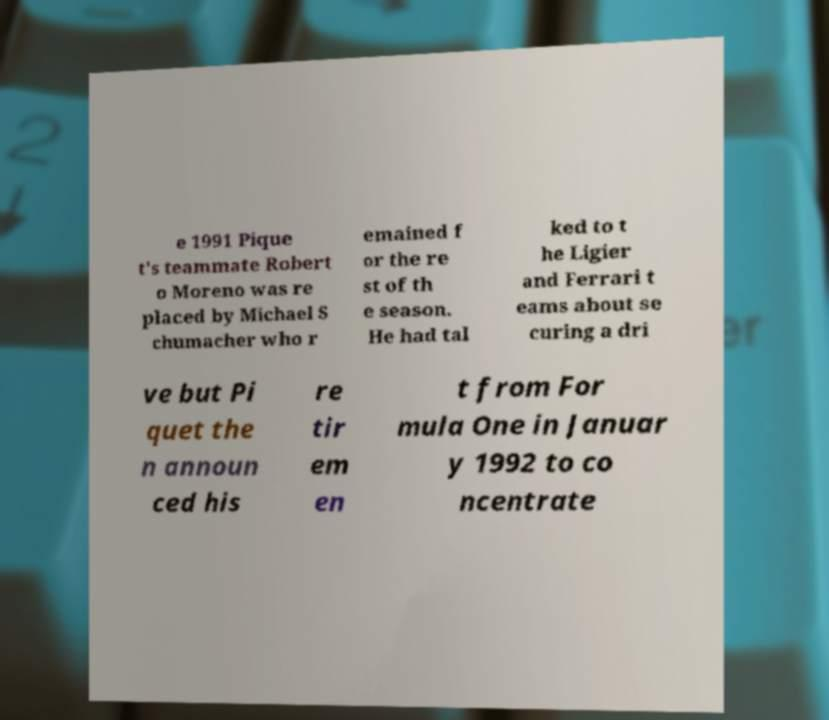Can you accurately transcribe the text from the provided image for me? e 1991 Pique t's teammate Robert o Moreno was re placed by Michael S chumacher who r emained f or the re st of th e season. He had tal ked to t he Ligier and Ferrari t eams about se curing a dri ve but Pi quet the n announ ced his re tir em en t from For mula One in Januar y 1992 to co ncentrate 